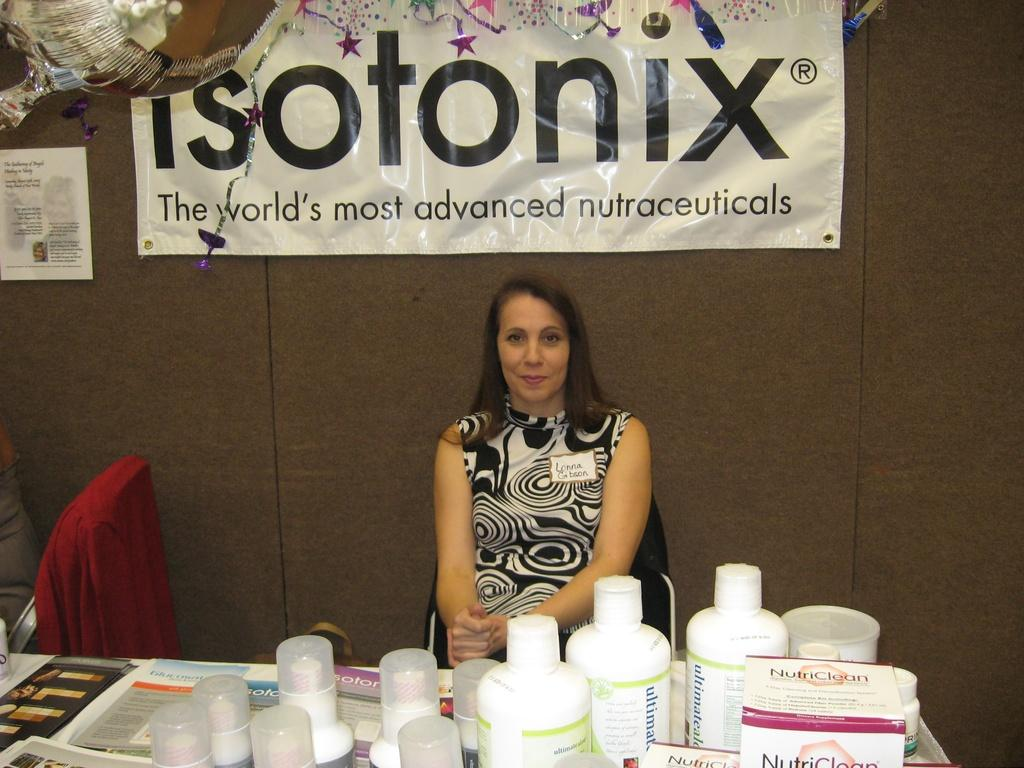Who is present in the image? There is a woman in the image. What is the woman doing in the image? The woman is sitting on a chair and smiling. What is in front of the woman? There is a table in front of the woman. What can be seen on the table? There are many things on the table. What is visible in the background of the image? There is a wall and a banner in the background of the image. What type of brick is being used to build the wall in the image? There is no mention of brick in the image, as the wall's construction material is not specified. What is the woman talking about in the image? The image does not provide any information about what the woman might be talking about, as her facial expression and body language suggest she is simply smiling. 